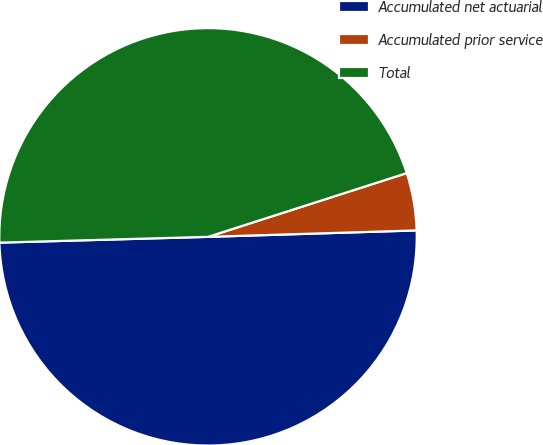Convert chart to OTSL. <chart><loc_0><loc_0><loc_500><loc_500><pie_chart><fcel>Accumulated net actuarial<fcel>Accumulated prior service<fcel>Total<nl><fcel>50.05%<fcel>4.45%<fcel>45.5%<nl></chart> 